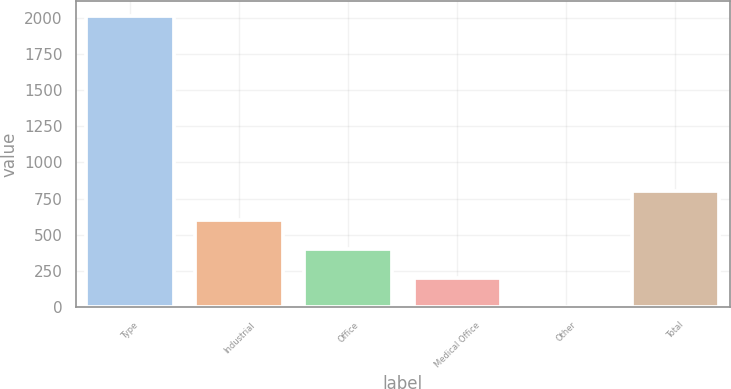<chart> <loc_0><loc_0><loc_500><loc_500><bar_chart><fcel>Type<fcel>Industrial<fcel>Office<fcel>Medical Office<fcel>Other<fcel>Total<nl><fcel>2011<fcel>603.86<fcel>402.84<fcel>201.82<fcel>0.8<fcel>804.88<nl></chart> 